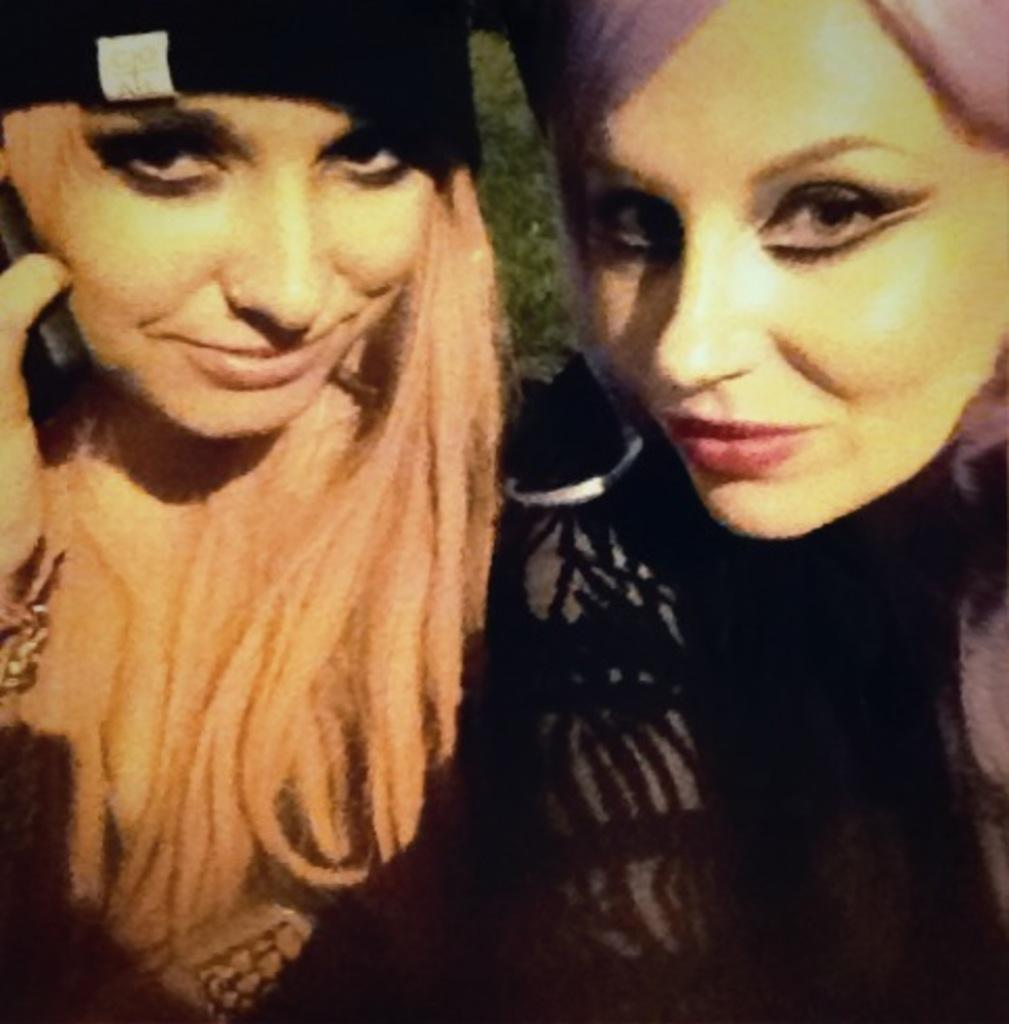What type of people can be seen in the image? There are ladies in the image. What type of hat is the lady wearing on the side in the image? There is no lady wearing a hat in the image. 